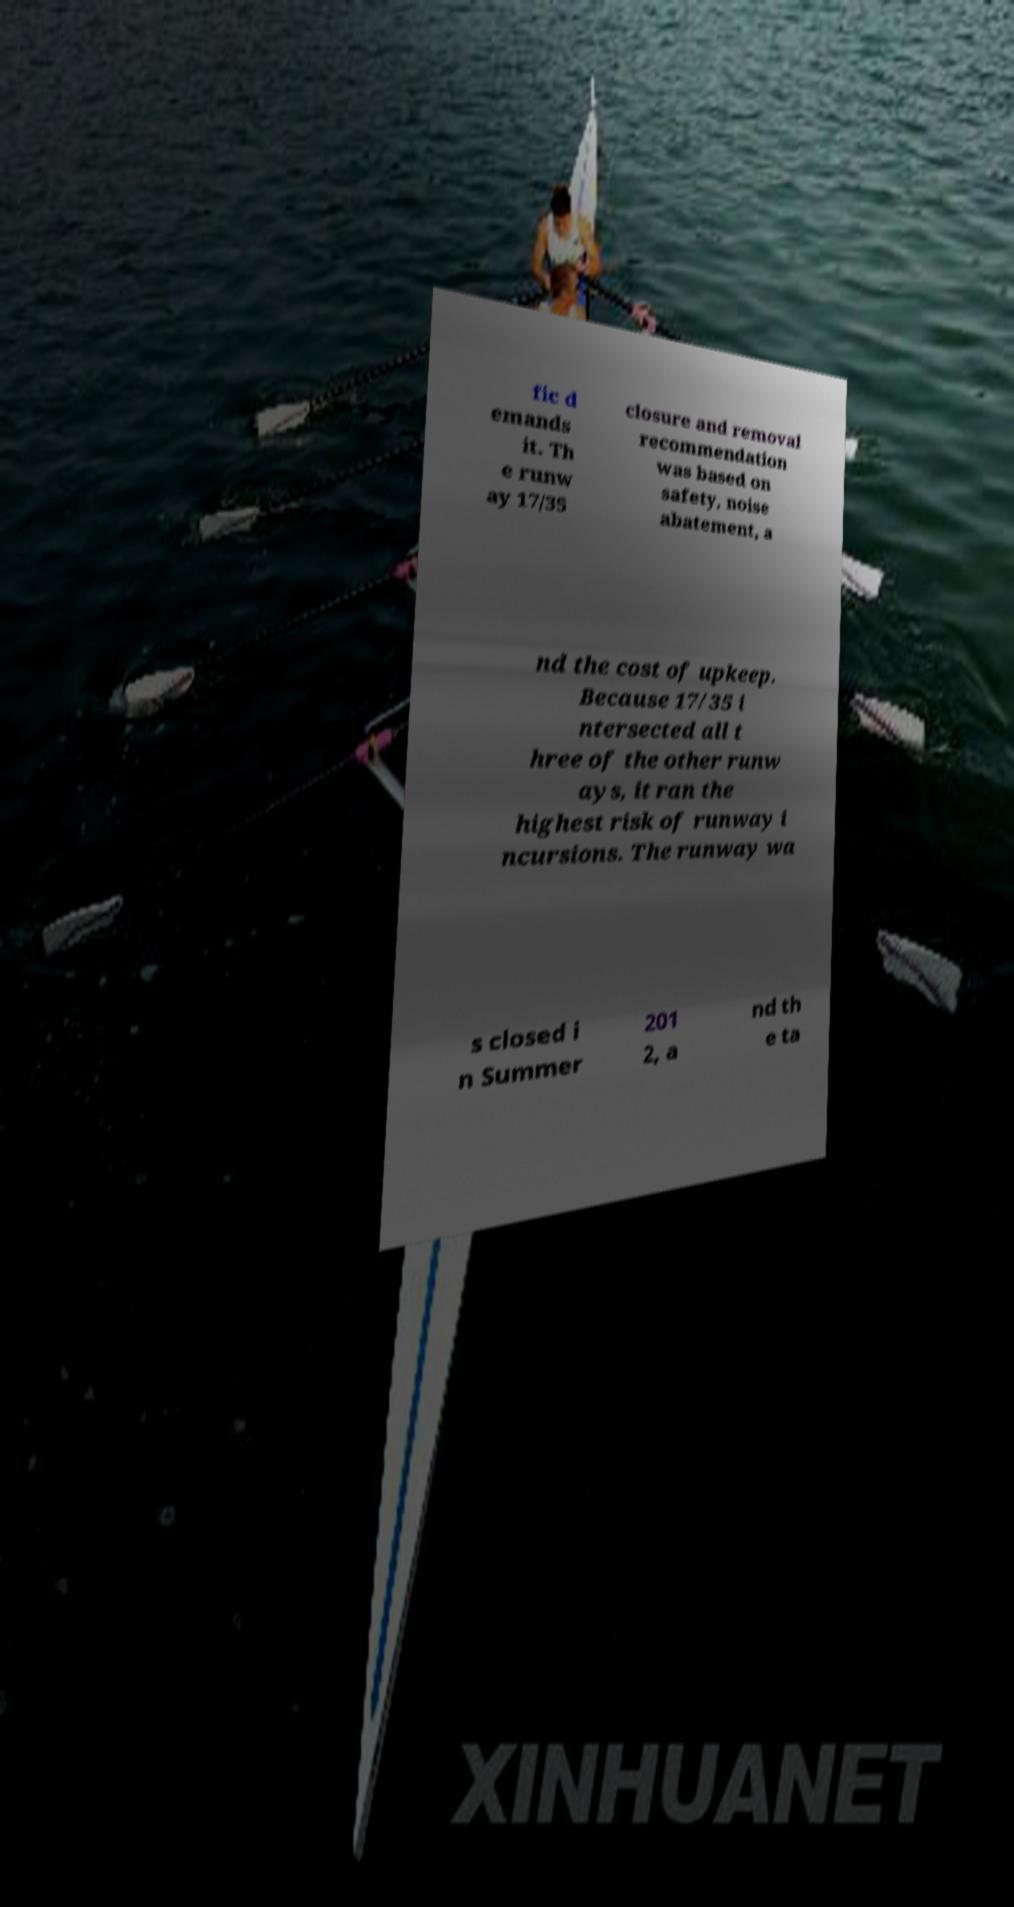Could you assist in decoding the text presented in this image and type it out clearly? fic d emands it. Th e runw ay 17/35 closure and removal recommendation was based on safety, noise abatement, a nd the cost of upkeep. Because 17/35 i ntersected all t hree of the other runw ays, it ran the highest risk of runway i ncursions. The runway wa s closed i n Summer 201 2, a nd th e ta 